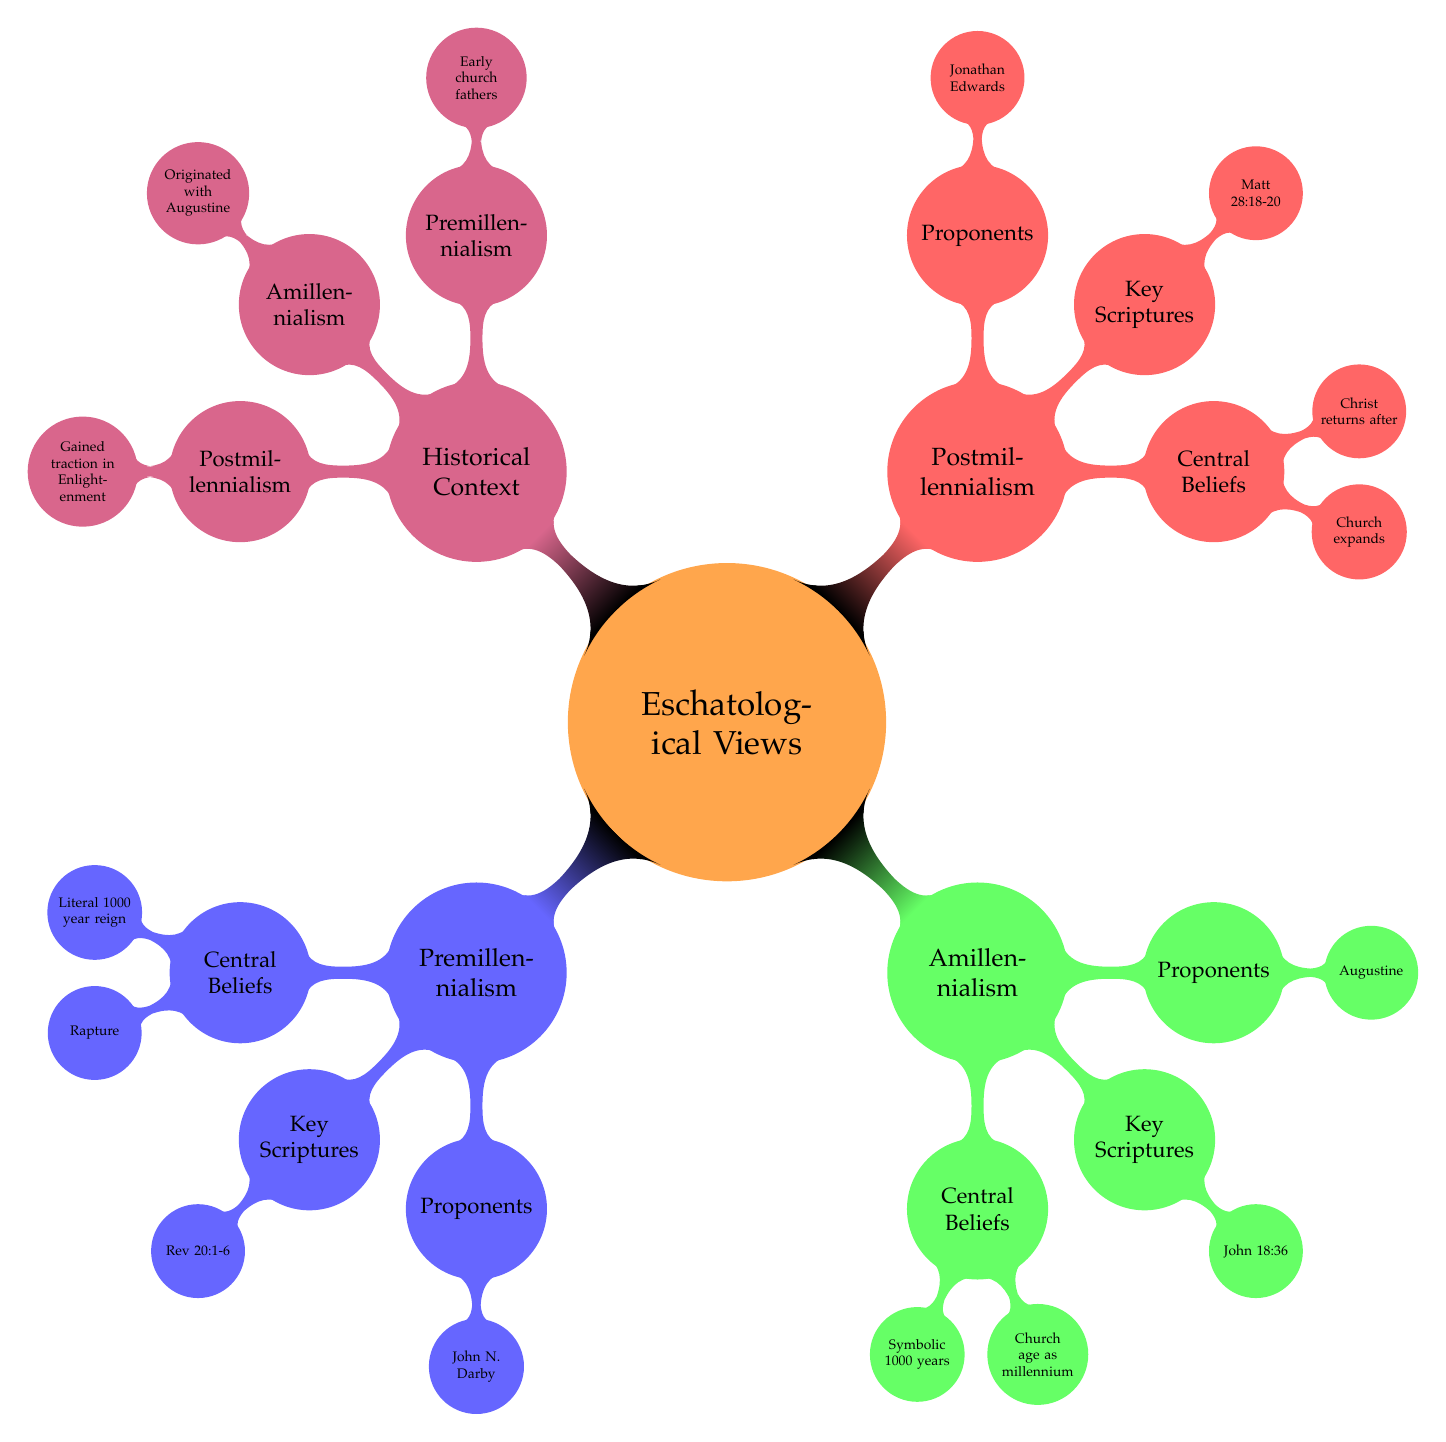What are the central beliefs of Premillennialism? The diagram indicates that the central beliefs of Premillennialism include a literal 1000 year reign of Christ on earth, a rapture occurring before or after a tribulation period, and a focus on a future kingdom.
Answer: A literal 1000 year reign, a rapture, focus on future kingdom What is one of the key scriptures for Amillennialism? According to the diagram, one of the key scriptures for Amillennialism is John 18:36. This can be found listed under the "Key Scriptures" categories for Amillennialism.
Answer: John 18:36 Who is a proponent of Postmillennialism? The diagram shows that one of the proponents of Postmillennialism is Jonathan Edwards. This information is located under the "Proponents" section for Postmillennialism.
Answer: Jonathan Edwards What historical context is associated with Amillennialism? The diagram mentions that Amillennialism originated with Augustine. This is specified under the "Historical Context" section for Amillennialism.
Answer: Originated with Augustine How many central beliefs are listed for Postmillennialism? In reviewing the diagram, Postmillennialism has two central beliefs listed: the church expands and influences society positively, and Christ returns after the millennium. Therefore, the total number is two.
Answer: Two Which eschatological view believes in a literal 1000 year reign of Christ on earth? The diagram clearly states that Premillennialism believes in a literal 1000 year reign of Christ on earth. This belief is part of its central beliefs shown in the diagram.
Answer: Premillennialism What relationship exists between Premillennialism and the early church? The diagram presents that Premillennialism has historical ties with the early church fathers like Justin Martyr and was popularized in the 19th and 20th centuries. This exhibits a historical relationship.
Answer: Early church fathers, popularized in 19th and 20th centuries How does the diagram categorize the different eschatological views? The diagram categorizes the eschatological views into three main views: Premillennialism, Amillennialism, and Postmillennialism. Each view has distinct sections under its label.
Answer: Three main views: Premillennialism, Amillennialism, Postmillennialism 